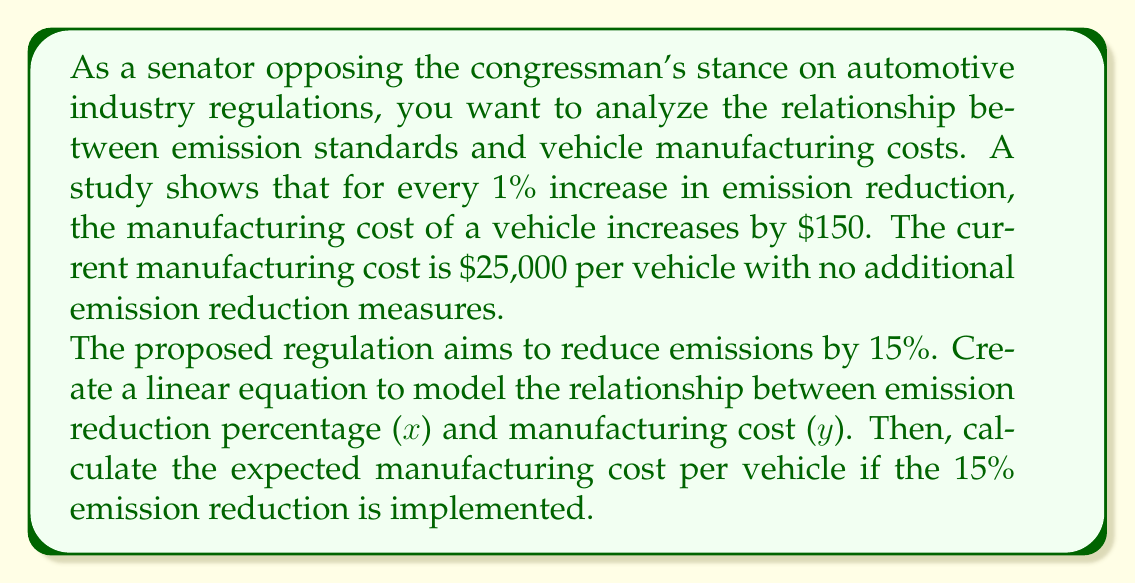Give your solution to this math problem. Let's approach this step-by-step:

1) First, we need to identify the variables:
   x = emission reduction percentage
   y = manufacturing cost per vehicle

2) We know two key pieces of information:
   - The base cost is $25,000 when there's no emission reduction (x = 0)
   - For every 1% increase in emission reduction, the cost increases by $150

3) We can use the point-slope form of a linear equation:
   $y - y_1 = m(x - x_1)$

   Where:
   $m$ = slope = $150 per 1% = 150$
   $(x_1, y_1)$ = initial point = $(0, 25000)$

4) Substituting these into the point-slope form:
   $y - 25000 = 150(x - 0)$

5) Simplify:
   $y - 25000 = 150x$

6) Rearrange to slope-intercept form $(y = mx + b)$:
   $y = 150x + 25000$

This is our linear equation modeling the relationship.

7) To find the cost at 15% emission reduction, we substitute x = 15:
   $y = 150(15) + 25000$
   $y = 2250 + 25000$
   $y = 27250$

Therefore, the expected manufacturing cost per vehicle with a 15% emission reduction would be $27,250.
Answer: The linear equation is: $y = 150x + 25000$, where x is the emission reduction percentage and y is the manufacturing cost in dollars.

The expected manufacturing cost per vehicle with a 15% emission reduction is $27,250. 